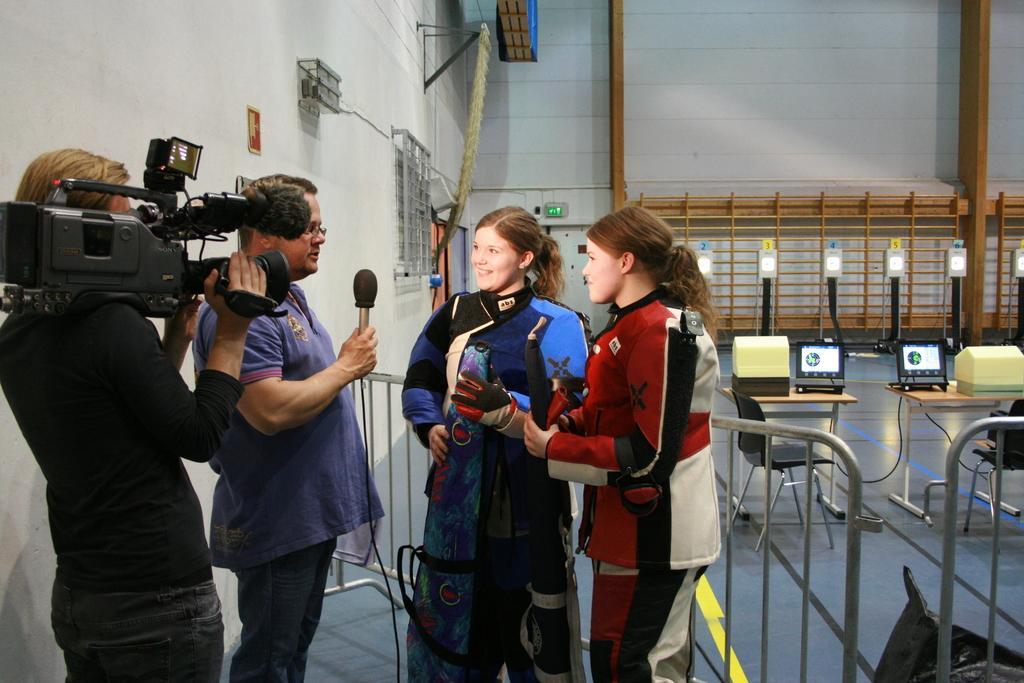In one or two sentences, can you explain what this image depicts? In this picture, we see four people are standing. The woman in the blue jacket is smiling. The man in violet T-shirt is holding a microphone in his hand. He might be interviewing the women. Beside him, the man in black T-shirt is holding a video camera in his hand. He is taking video. Behind them, we see a railing. Behind the man, we see a white wall. On the right side, we see tables on which laptops and boxes in yellow and black color are placed. We even see the chairs. In the background, we see a white wall and we see some tables which look like podiums with numbers written on it. 